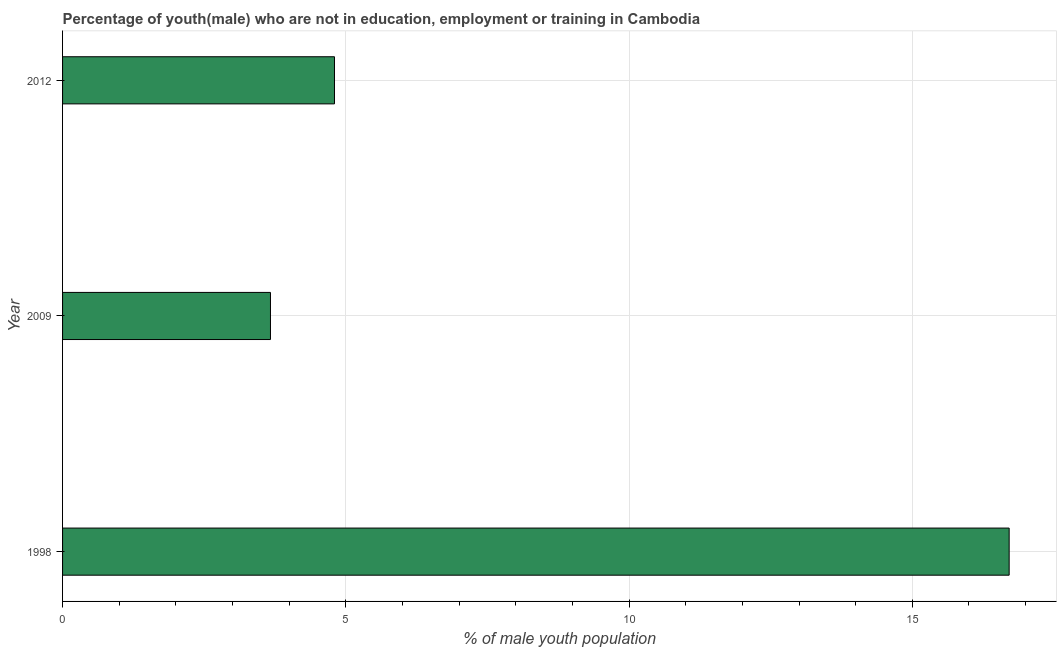What is the title of the graph?
Your answer should be compact. Percentage of youth(male) who are not in education, employment or training in Cambodia. What is the label or title of the X-axis?
Give a very brief answer. % of male youth population. What is the label or title of the Y-axis?
Provide a short and direct response. Year. What is the unemployed male youth population in 1998?
Provide a short and direct response. 16.71. Across all years, what is the maximum unemployed male youth population?
Offer a very short reply. 16.71. Across all years, what is the minimum unemployed male youth population?
Ensure brevity in your answer.  3.67. What is the sum of the unemployed male youth population?
Provide a succinct answer. 25.18. What is the difference between the unemployed male youth population in 1998 and 2012?
Keep it short and to the point. 11.91. What is the average unemployed male youth population per year?
Make the answer very short. 8.39. What is the median unemployed male youth population?
Make the answer very short. 4.8. What is the ratio of the unemployed male youth population in 1998 to that in 2012?
Ensure brevity in your answer.  3.48. Is the unemployed male youth population in 1998 less than that in 2009?
Offer a very short reply. No. What is the difference between the highest and the second highest unemployed male youth population?
Give a very brief answer. 11.91. Is the sum of the unemployed male youth population in 1998 and 2012 greater than the maximum unemployed male youth population across all years?
Ensure brevity in your answer.  Yes. What is the difference between the highest and the lowest unemployed male youth population?
Provide a short and direct response. 13.04. How many bars are there?
Offer a terse response. 3. Are all the bars in the graph horizontal?
Your answer should be very brief. Yes. How many years are there in the graph?
Make the answer very short. 3. What is the difference between two consecutive major ticks on the X-axis?
Offer a very short reply. 5. What is the % of male youth population in 1998?
Ensure brevity in your answer.  16.71. What is the % of male youth population of 2009?
Make the answer very short. 3.67. What is the % of male youth population in 2012?
Make the answer very short. 4.8. What is the difference between the % of male youth population in 1998 and 2009?
Give a very brief answer. 13.04. What is the difference between the % of male youth population in 1998 and 2012?
Your answer should be very brief. 11.91. What is the difference between the % of male youth population in 2009 and 2012?
Give a very brief answer. -1.13. What is the ratio of the % of male youth population in 1998 to that in 2009?
Keep it short and to the point. 4.55. What is the ratio of the % of male youth population in 1998 to that in 2012?
Ensure brevity in your answer.  3.48. What is the ratio of the % of male youth population in 2009 to that in 2012?
Provide a short and direct response. 0.77. 